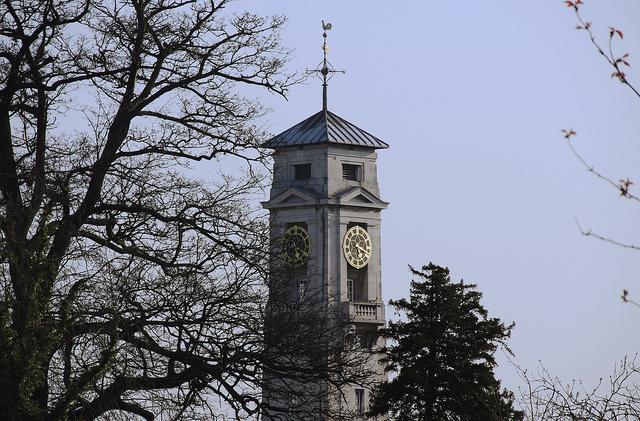How many clock faces are there?
Give a very brief answer. 2. 